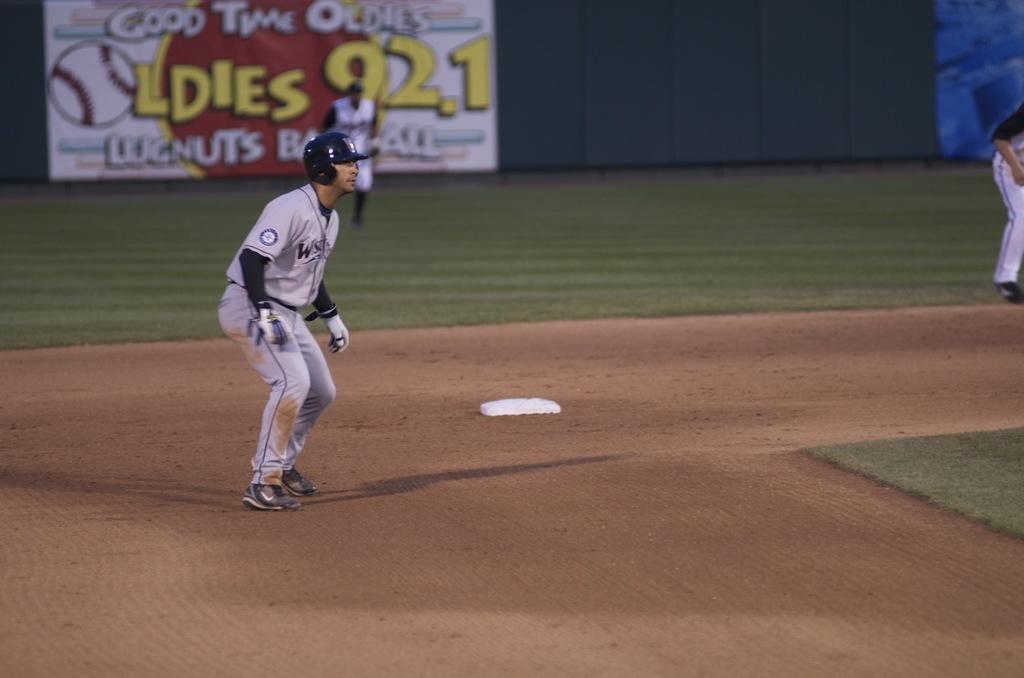What is the type of oldies on the sign?
Offer a terse response. Good time. 